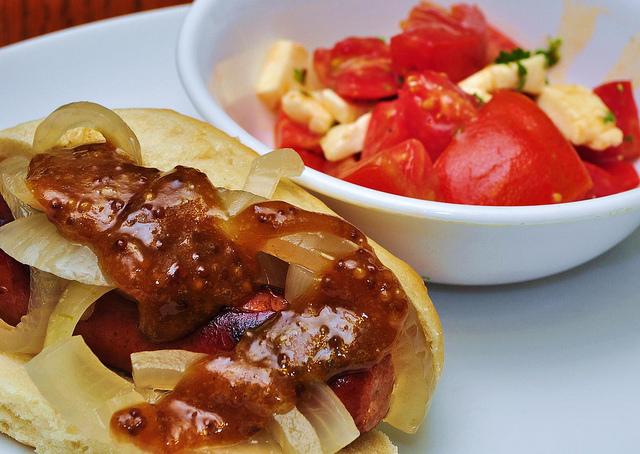What color are the plates?
Write a very short answer. White. Is that gravy on top of the food?
Answer briefly. No. Has the meal begun?
Be succinct. No. Are the objects with the red coloring edible for humans?
Quick response, please. Yes. 